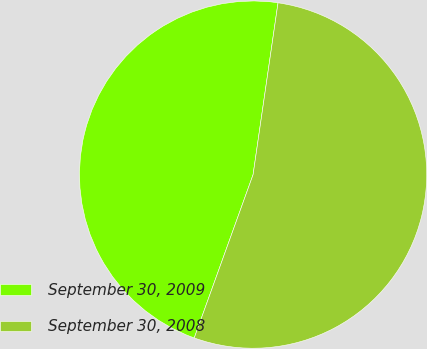Convert chart. <chart><loc_0><loc_0><loc_500><loc_500><pie_chart><fcel>September 30, 2009<fcel>September 30, 2008<nl><fcel>46.79%<fcel>53.21%<nl></chart> 